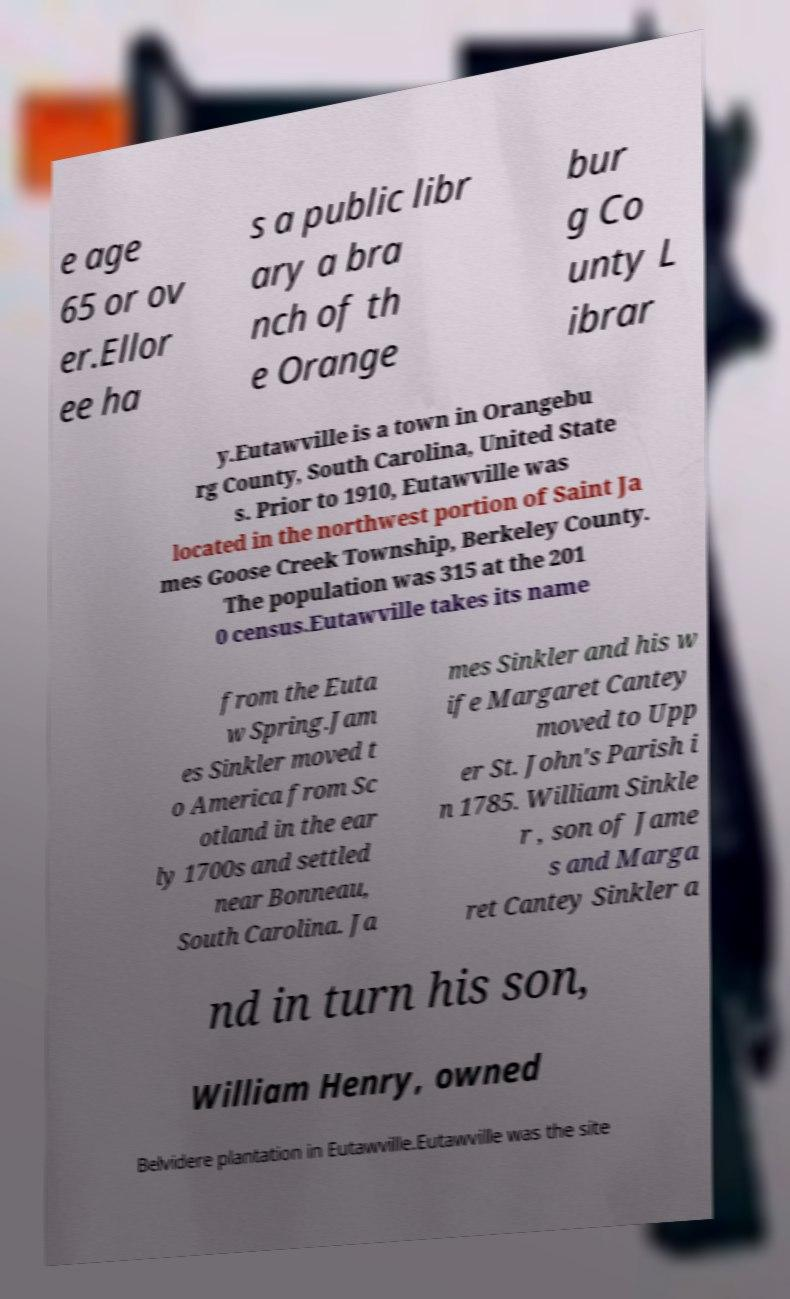Could you assist in decoding the text presented in this image and type it out clearly? e age 65 or ov er.Ellor ee ha s a public libr ary a bra nch of th e Orange bur g Co unty L ibrar y.Eutawville is a town in Orangebu rg County, South Carolina, United State s. Prior to 1910, Eutawville was located in the northwest portion of Saint Ja mes Goose Creek Township, Berkeley County. The population was 315 at the 201 0 census.Eutawville takes its name from the Euta w Spring.Jam es Sinkler moved t o America from Sc otland in the ear ly 1700s and settled near Bonneau, South Carolina. Ja mes Sinkler and his w ife Margaret Cantey moved to Upp er St. John's Parish i n 1785. William Sinkle r , son of Jame s and Marga ret Cantey Sinkler a nd in turn his son, William Henry, owned Belvidere plantation in Eutawville.Eutawville was the site 